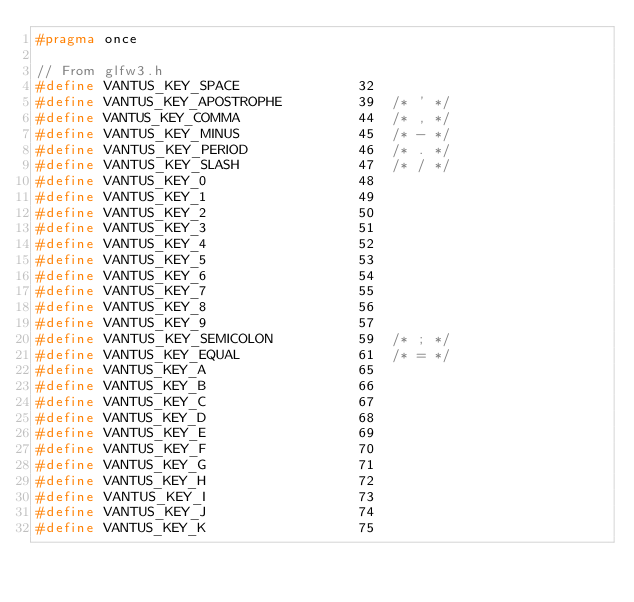<code> <loc_0><loc_0><loc_500><loc_500><_C_>#pragma once

// From glfw3.h
#define VANTUS_KEY_SPACE              32
#define VANTUS_KEY_APOSTROPHE         39  /* ' */
#define VANTUS_KEY_COMMA              44  /* , */
#define VANTUS_KEY_MINUS              45  /* - */
#define VANTUS_KEY_PERIOD             46  /* . */
#define VANTUS_KEY_SLASH              47  /* / */
#define VANTUS_KEY_0                  48
#define VANTUS_KEY_1                  49
#define VANTUS_KEY_2                  50
#define VANTUS_KEY_3                  51
#define VANTUS_KEY_4                  52
#define VANTUS_KEY_5                  53
#define VANTUS_KEY_6                  54
#define VANTUS_KEY_7                  55
#define VANTUS_KEY_8                  56
#define VANTUS_KEY_9                  57
#define VANTUS_KEY_SEMICOLON          59  /* ; */
#define VANTUS_KEY_EQUAL              61  /* = */
#define VANTUS_KEY_A                  65
#define VANTUS_KEY_B                  66
#define VANTUS_KEY_C                  67
#define VANTUS_KEY_D                  68
#define VANTUS_KEY_E                  69
#define VANTUS_KEY_F                  70
#define VANTUS_KEY_G                  71
#define VANTUS_KEY_H                  72
#define VANTUS_KEY_I                  73
#define VANTUS_KEY_J                  74
#define VANTUS_KEY_K                  75</code> 